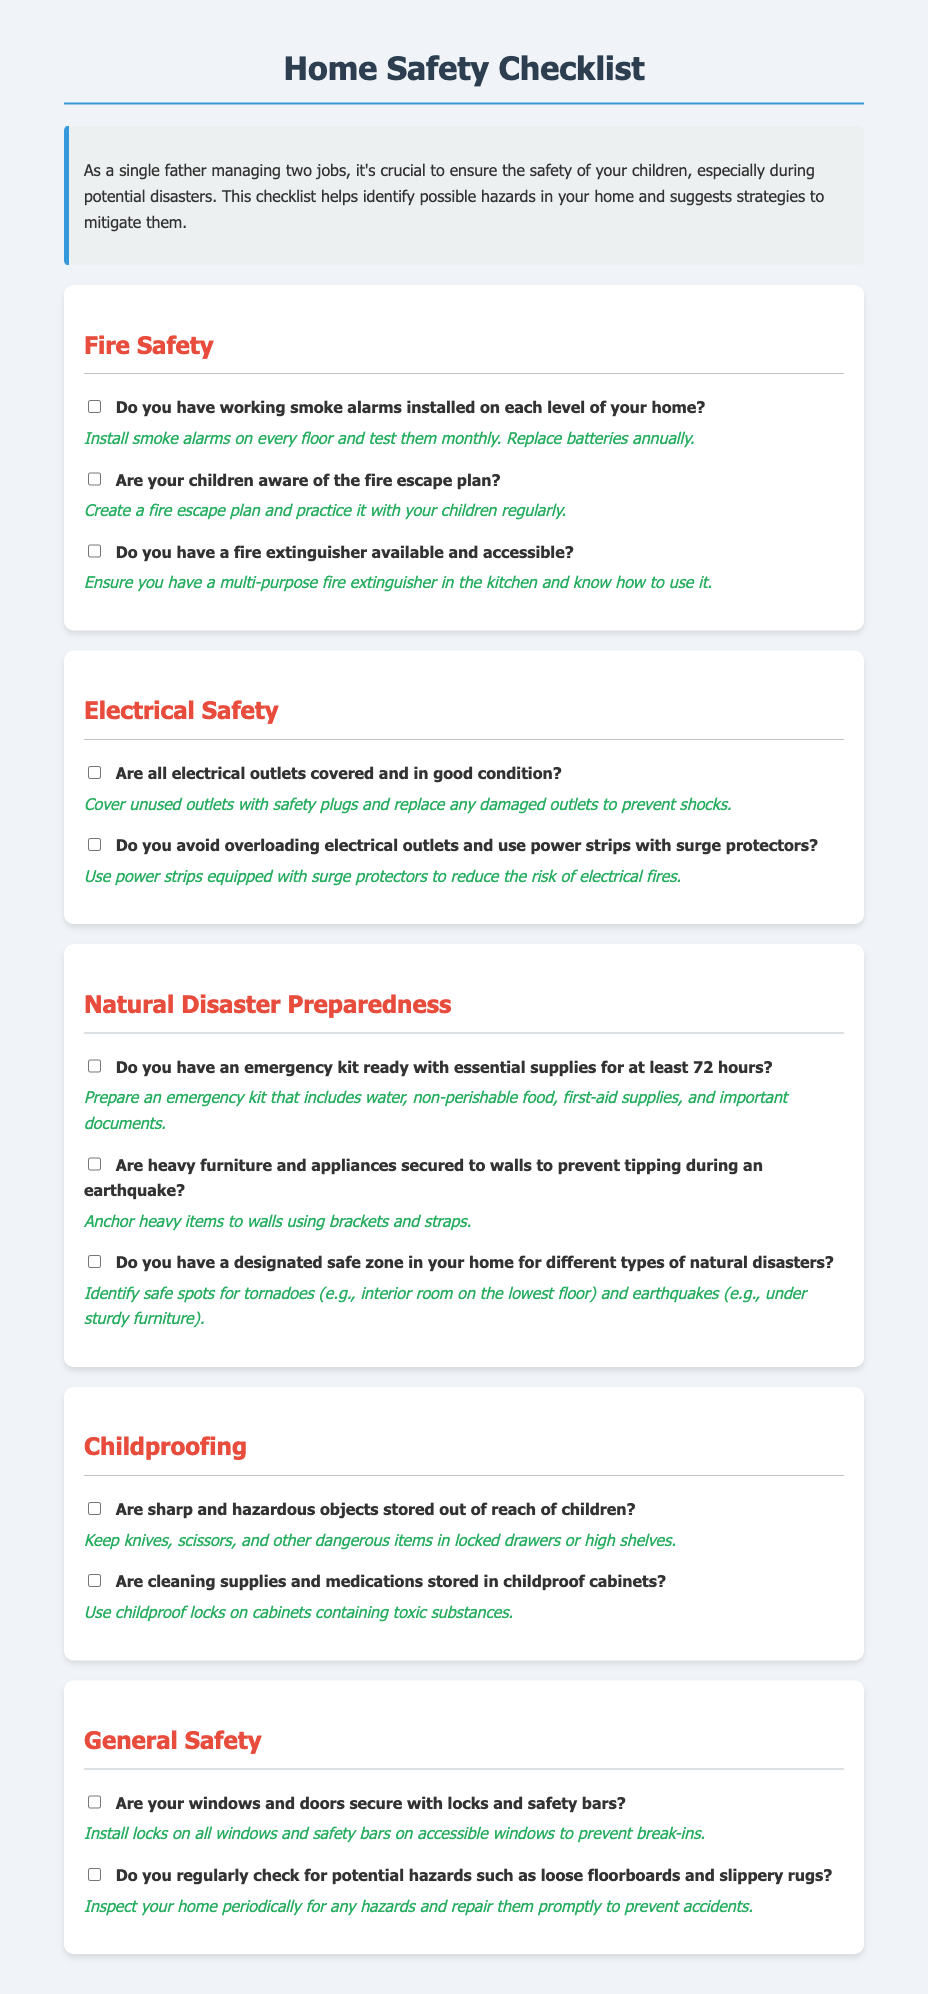What should you do to your smoke alarms? The document suggests that you should install smoke alarms on every floor and test them monthly. Replace batteries annually.
Answer: Install and test monthly What is included in the emergency kit? The document states that the emergency kit should include water, non-perishable food, first-aid supplies, and important documents.
Answer: Water, food, first-aid, documents Where should heavy furniture be secured? It is recommended in the document to anchor heavy items to walls using brackets and straps to prevent tipping during an earthquake.
Answer: To walls What do you use to cover unused outlets? The document mentions using safety plugs to cover unused outlets.
Answer: Safety plugs What type of fire extinguisher is suggested? The document recommends ensuring you have a multi-purpose fire extinguisher in the kitchen and knowing how to use it.
Answer: Multi-purpose extinguisher Are cleaning supplies stored properly? The document advises to use childproof locks on cabinets containing toxic substances to keep cleaning supplies safe.
Answer: Yes Is there a fire escape plan? The document indicates that you should create a fire escape plan and practice it with your children regularly.
Answer: Yes 